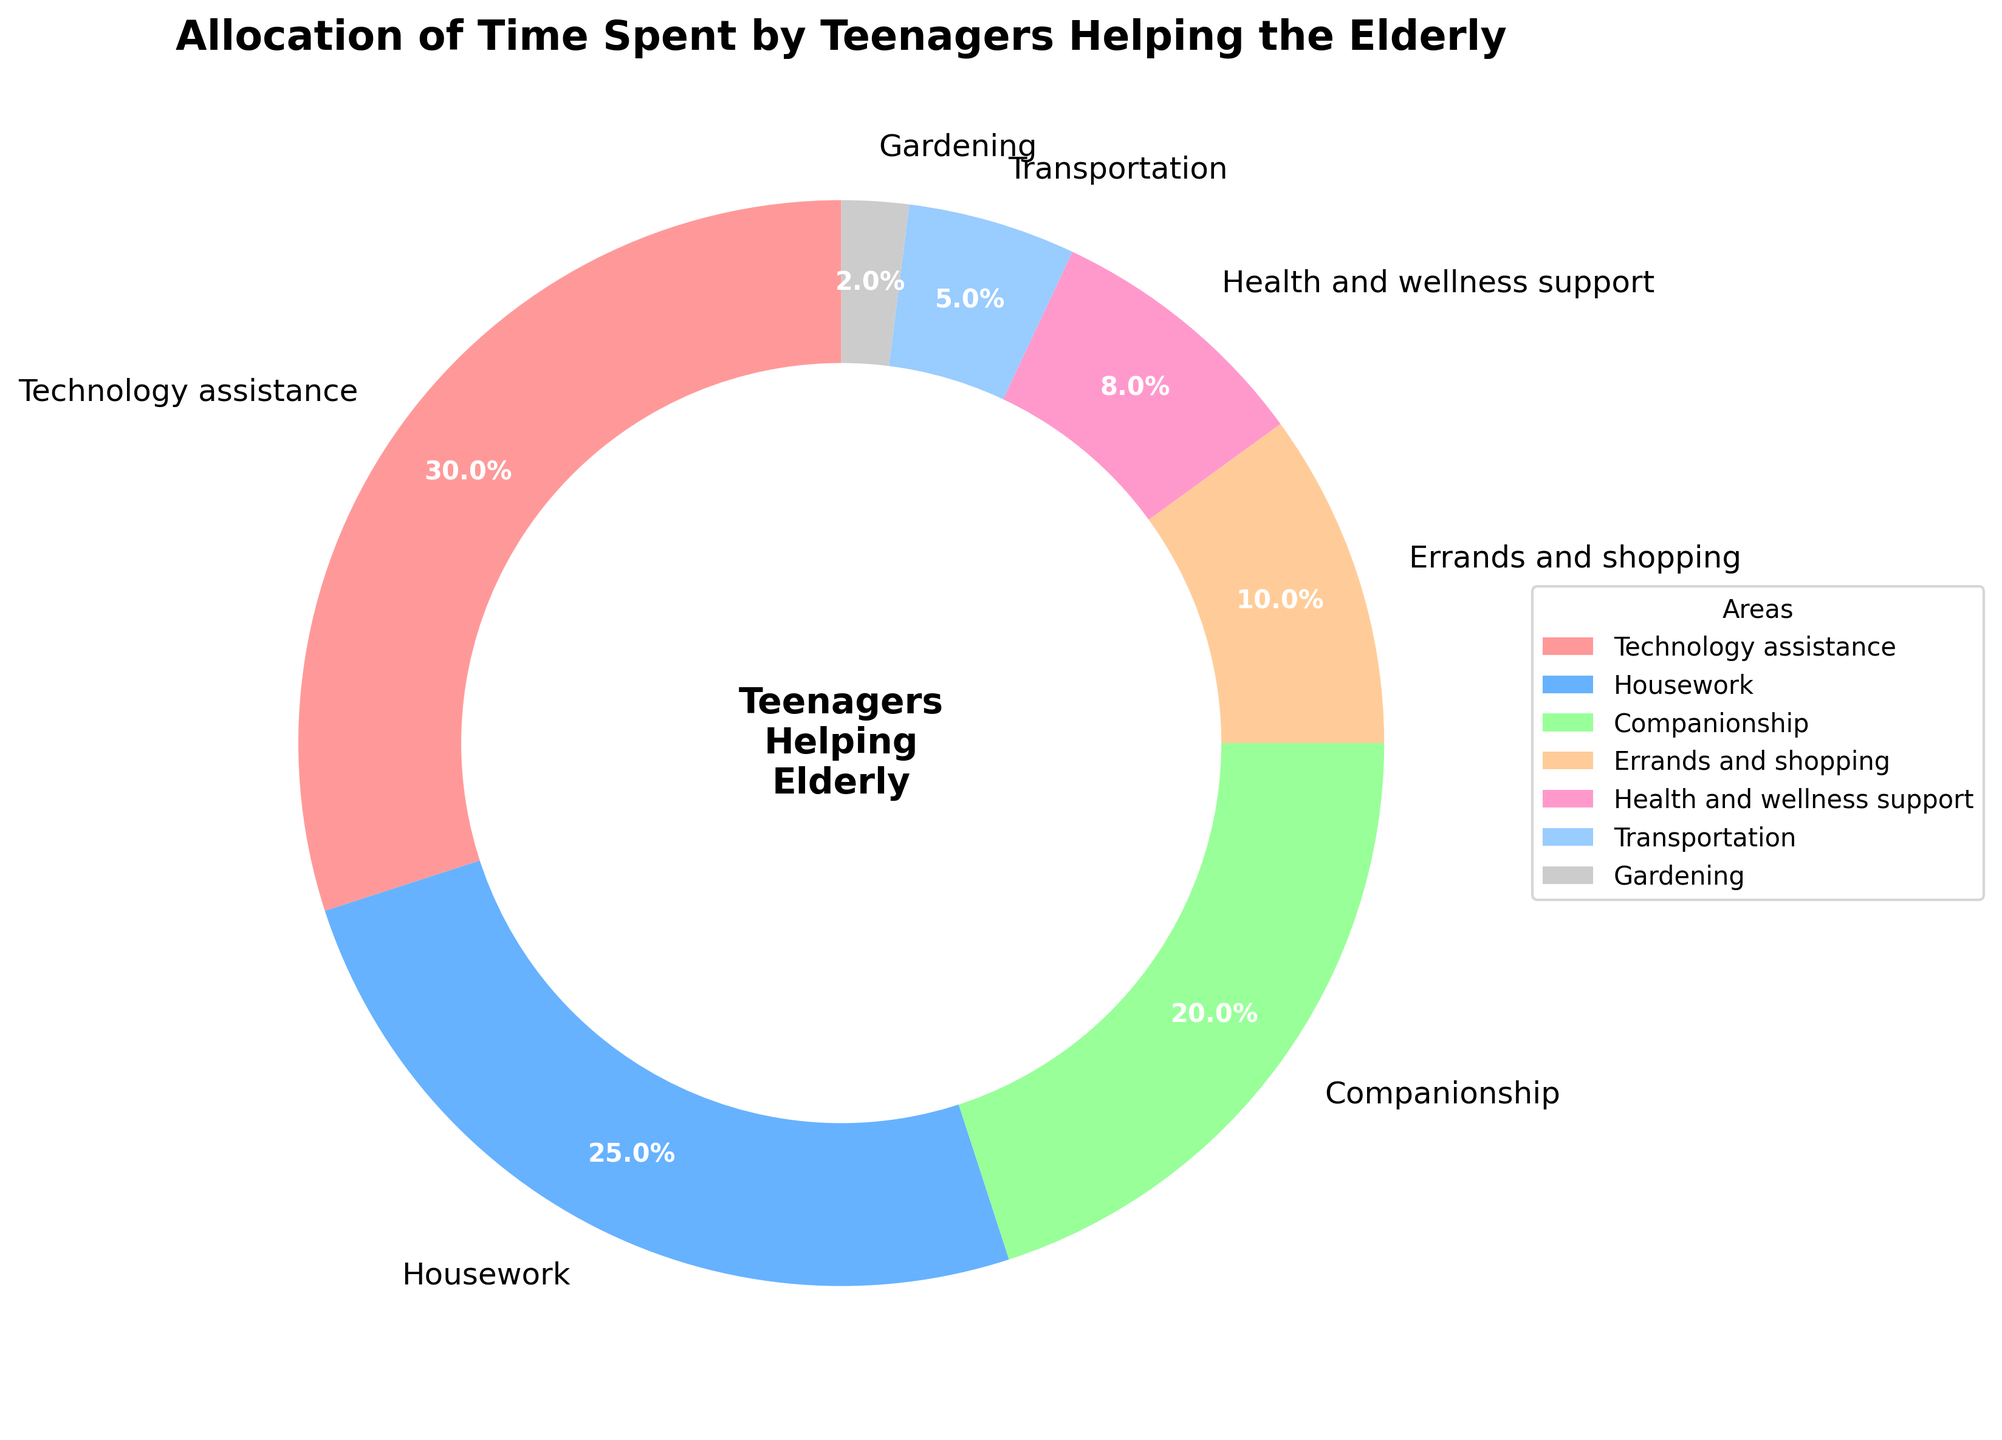Which area do teenagers spend the most time helping the elderly? By looking at the pie chart, the largest segment will indicate the area where teenagers spend the most time. The segment labeled "Technology assistance" takes up the largest portion.
Answer: Technology assistance Which two areas combined make up half of the total time spent by teenagers? From the pie chart, "Technology assistance" is 30% and "Housework" is 25%. Adding these two (30% + 25%) equals 55%, which is more than half. Therefore, the two areas are Technology assistance and Housework.
Answer: Technology assistance and Housework Which area receives the least amount of time from teenagers? The smallest slice of the pie chart will indicate the area with the least time allocation. The segment for "Gardening" is the smallest at 2%.
Answer: Gardening If you combine the time spent on Errands and shopping with Health and wellness support, how much time is that in total? According to the pie chart, Errands and shopping is 10% and Health and wellness support is 8%. Adding these values gives 10% + 8% = 18%.
Answer: 18% Is the time spent on Companionship greater than the time spent on Health and wellness support? Comparing the two segments on the pie chart, Companionship is 20%, and Health and wellness support is 8%. Since 20% is greater than 8%, the answer is yes.
Answer: Yes Which area is represented by the blue segment in the pie chart? Observing the pie chart, the blue segment corresponds to the label "Housework." This can be seen from the color-coding provided.
Answer: Housework What percentage of time is not spent on Technology assistance or Housework? The time spent on Technology assistance is 30% and Housework is 25%. Summing these gives 55%. The total percentage not spent on these areas is 100% - 55% = 45%.
Answer: 45% How does the time spent on Transportation compare with that spent on Gardening? From the pie chart, Transportation is 5%, and Gardening is 2%. Thus, teenagers spend more time on Transportation than Gardening.
Answer: More time on Transportation What is the difference between the time allocated to Companionship and Transportation? The pie chart shows Companionship at 20% and Transportation at 5%. The difference is 20% - 5% = 15%.
Answer: 15% 